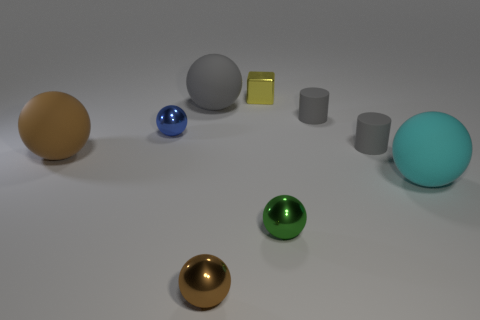What is the shape of the small blue metallic thing?
Your answer should be very brief. Sphere. How many other big spheres have the same material as the gray sphere?
Your answer should be compact. 2. What color is the small block that is made of the same material as the tiny brown object?
Provide a short and direct response. Yellow. There is a brown matte sphere; does it have the same size as the brown ball that is to the right of the gray ball?
Make the answer very short. No. What is the large sphere that is on the right side of the small metallic object that is in front of the shiny sphere on the right side of the brown shiny sphere made of?
Offer a terse response. Rubber. What number of things are brown matte cubes or tiny gray objects?
Your answer should be compact. 2. Is the color of the small sphere behind the brown rubber sphere the same as the object in front of the tiny green metal sphere?
Give a very brief answer. No. What shape is the brown rubber thing that is the same size as the cyan rubber thing?
Ensure brevity in your answer.  Sphere. What number of objects are either small gray things behind the tiny blue metallic object or large spheres to the right of the yellow metal object?
Keep it short and to the point. 2. Is the number of tiny rubber objects less than the number of yellow metal cubes?
Make the answer very short. No. 